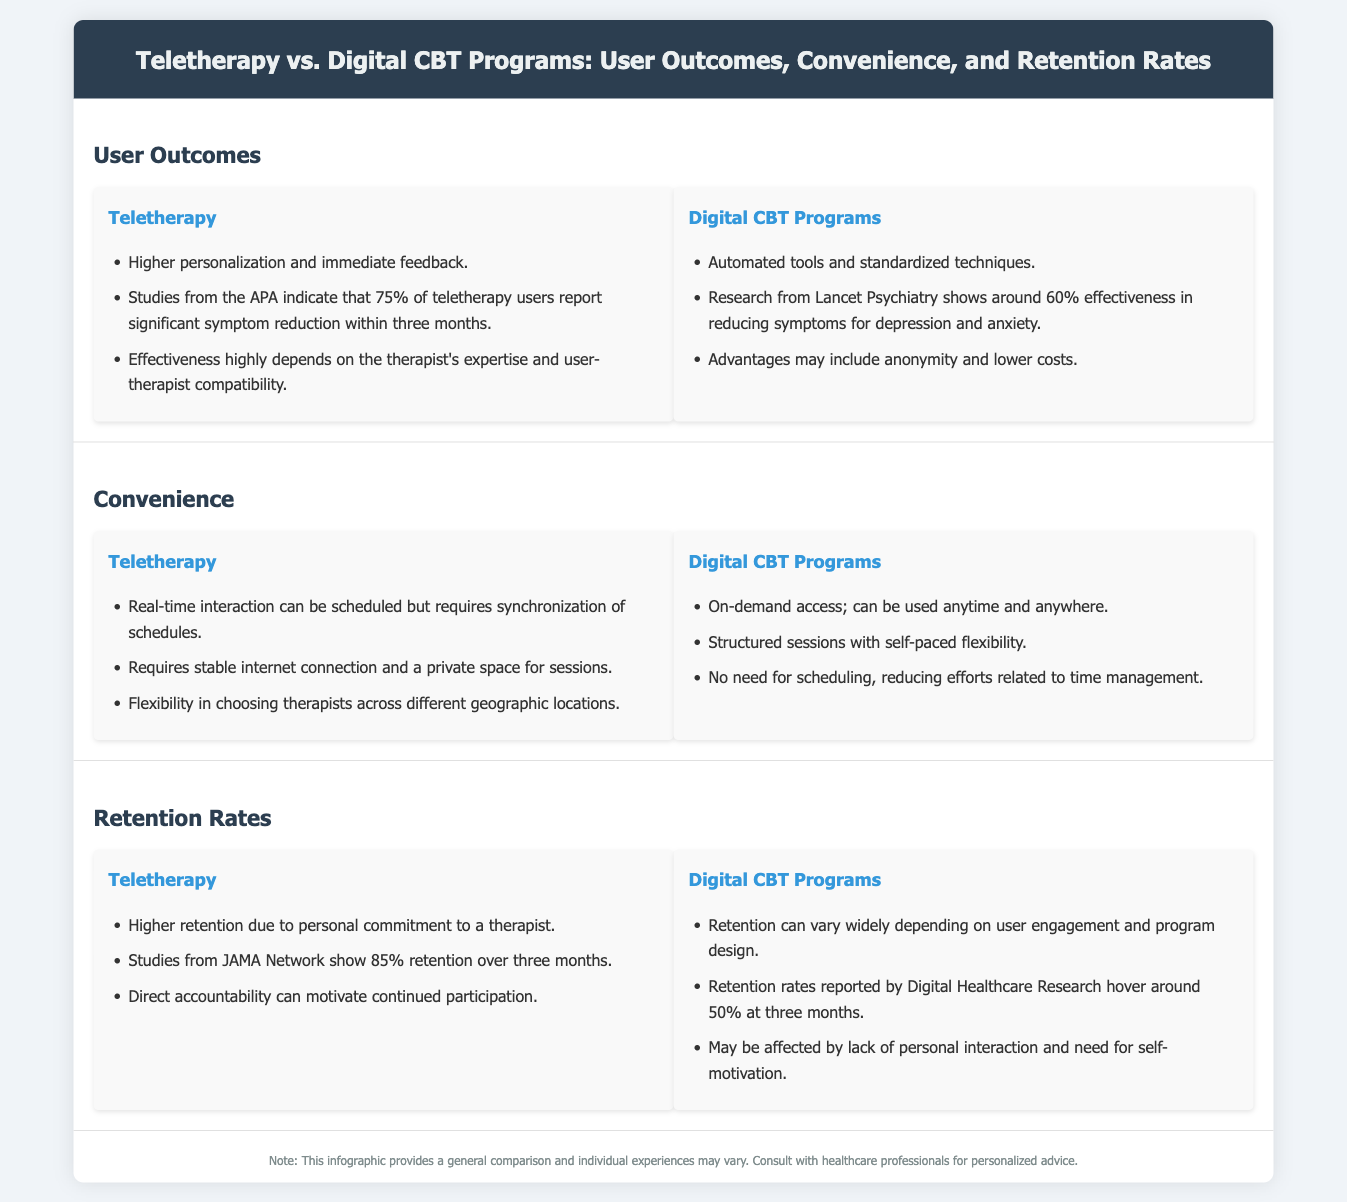What is the effectiveness percentage for teletherapy users reporting significant symptom reduction? The document states that 75% of teletherapy users report significant symptom reduction within three months.
Answer: 75% What is the effectiveness percentage of Digital CBT Programs for reducing symptoms? Research from Lancet Psychiatry shows around 60% effectiveness in reducing symptoms for depression and anxiety.
Answer: 60% How long is the retention rate for teletherapy according to studies from JAMA Network? The document mentions that studies show 85% retention over three months for teletherapy.
Answer: 85% What factor can lead to higher retention rates in teletherapy? The document indicates that higher retention is due to personal commitment to a therapist.
Answer: Personal commitment What is a significant convenience aspect of Digital CBT Programs? The infographic states that Digital CBT Programs provide on-demand access and can be used anytime and anywhere.
Answer: On-demand access How does personal interaction affect retention rates in Digital CBT Programs? The document notes that retention may be affected by lack of personal interaction and need for self-motivation.
Answer: Lack of personal interaction What percentage of users in Digital CBT Programs show retention at three months? The document states that retention rates hover around 50% at three months for Digital CBT Programs.
Answer: 50% Which method requires stable internet and a private space for interactions? The document specifies that teletherapy requires a stable internet connection and a private space for sessions.
Answer: Teletherapy What is an advantage of using teletherapy over Digital CBT Programs? The document mentions that teletherapy offers higher personalization and immediate feedback.
Answer: Higher personalization What type of document is this comparison based on? The structure and content of the document indicate that it is an infographic comparing teletherapy and Digital CBT Programs.
Answer: Infographic 